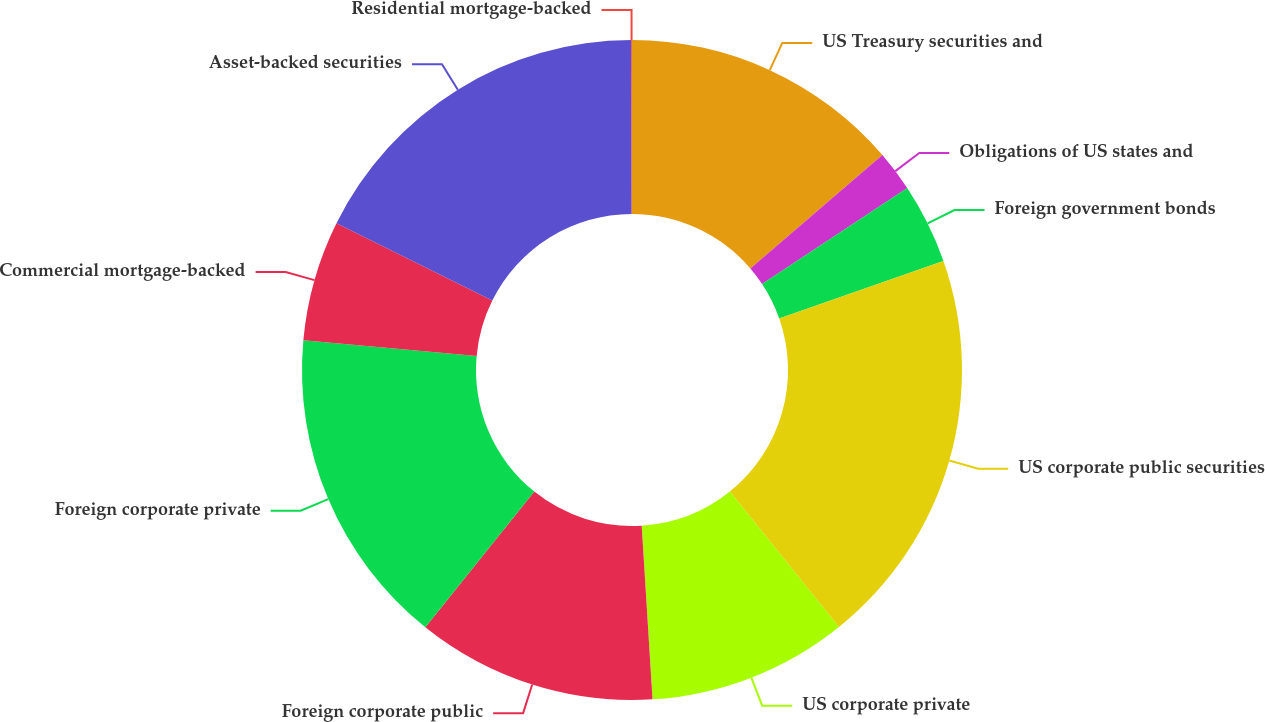Convert chart. <chart><loc_0><loc_0><loc_500><loc_500><pie_chart><fcel>US Treasury securities and<fcel>Obligations of US states and<fcel>Foreign government bonds<fcel>US corporate public securities<fcel>US corporate private<fcel>Foreign corporate public<fcel>Foreign corporate private<fcel>Commercial mortgage-backed<fcel>Asset-backed securities<fcel>Residential mortgage-backed<nl><fcel>13.71%<fcel>1.99%<fcel>3.94%<fcel>19.57%<fcel>9.8%<fcel>11.76%<fcel>15.67%<fcel>5.9%<fcel>17.62%<fcel>0.04%<nl></chart> 